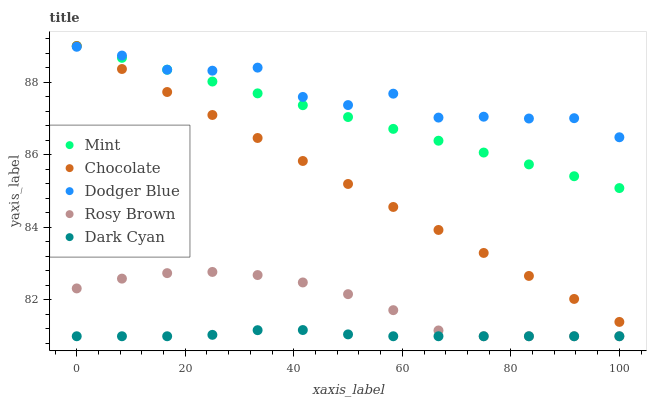Does Dark Cyan have the minimum area under the curve?
Answer yes or no. Yes. Does Dodger Blue have the maximum area under the curve?
Answer yes or no. Yes. Does Rosy Brown have the minimum area under the curve?
Answer yes or no. No. Does Rosy Brown have the maximum area under the curve?
Answer yes or no. No. Is Chocolate the smoothest?
Answer yes or no. Yes. Is Dodger Blue the roughest?
Answer yes or no. Yes. Is Rosy Brown the smoothest?
Answer yes or no. No. Is Rosy Brown the roughest?
Answer yes or no. No. Does Dark Cyan have the lowest value?
Answer yes or no. Yes. Does Dodger Blue have the lowest value?
Answer yes or no. No. Does Chocolate have the highest value?
Answer yes or no. Yes. Does Dodger Blue have the highest value?
Answer yes or no. No. Is Rosy Brown less than Mint?
Answer yes or no. Yes. Is Mint greater than Dark Cyan?
Answer yes or no. Yes. Does Dark Cyan intersect Rosy Brown?
Answer yes or no. Yes. Is Dark Cyan less than Rosy Brown?
Answer yes or no. No. Is Dark Cyan greater than Rosy Brown?
Answer yes or no. No. Does Rosy Brown intersect Mint?
Answer yes or no. No. 